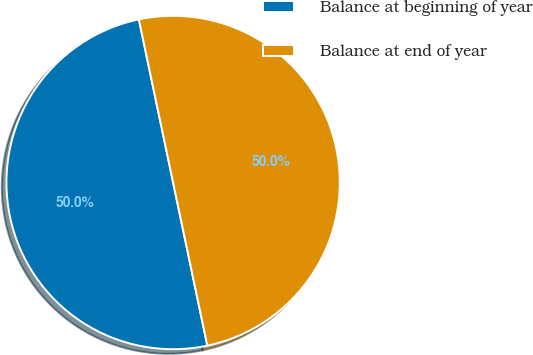Convert chart. <chart><loc_0><loc_0><loc_500><loc_500><pie_chart><fcel>Balance at beginning of year<fcel>Balance at end of year<nl><fcel>50.0%<fcel>50.0%<nl></chart> 